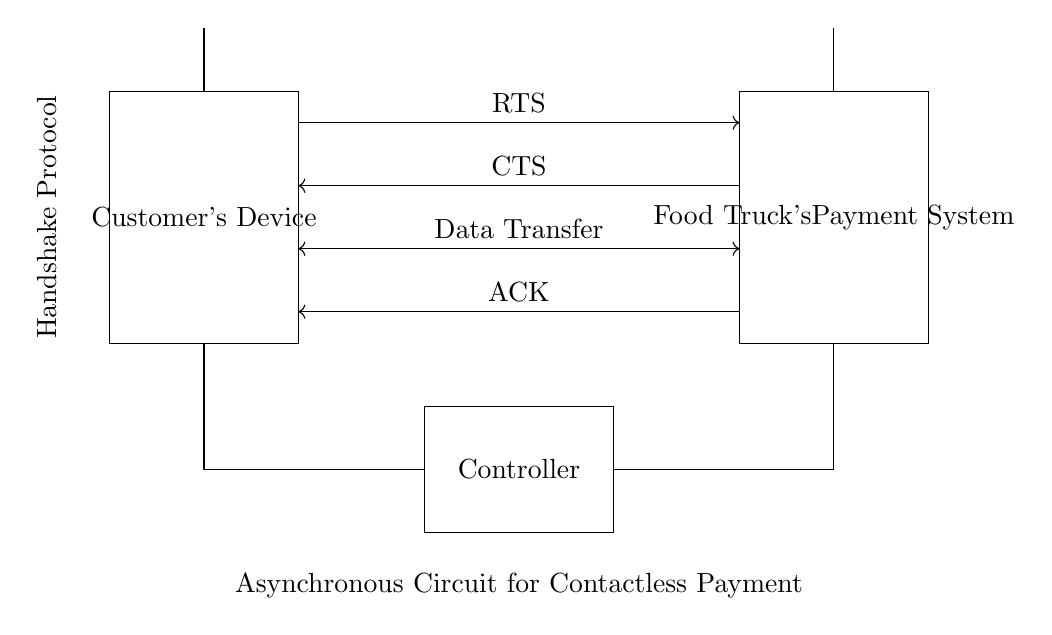What is the main function of the controller? The controller is responsible for managing the communication and process of the handshake protocol between the customer's device and the food truck's payment system. It coordinates the signals like RTS, CTS, data transfer, and ACK.
Answer: managing communication How many antennas are present in the circuit? There are two antennas in the circuit, one for the customer's device and one for the food truck's payment system. This allows for contactless communication between the devices.
Answer: two What does RTS stand for? RTS stands for "Request to Send." It is the signal initiated by the customer's device indicating that it wants to start the communication process with the payment system.
Answer: Request to Send What is the direction of the ACK signal? The ACK signal is directed from the food truck's payment system to the customer's device, indicating that the data transfer has been successfully completed.
Answer: from food truck's payment system to customer's device What type of circuit is represented in the diagram? The circuit is an asynchronous circuit designed specifically for implementing a handshake protocol for contactless payments. This type ensures that signals are sent and received without the need for a clock signal.
Answer: asynchronous circuit What is the purpose of the CTS signal? The CTS signal stands for "Clear to Send," and it is sent from the food truck's payment system back to the customer's device to confirm that it can proceed with sending data.
Answer: confirm sending 